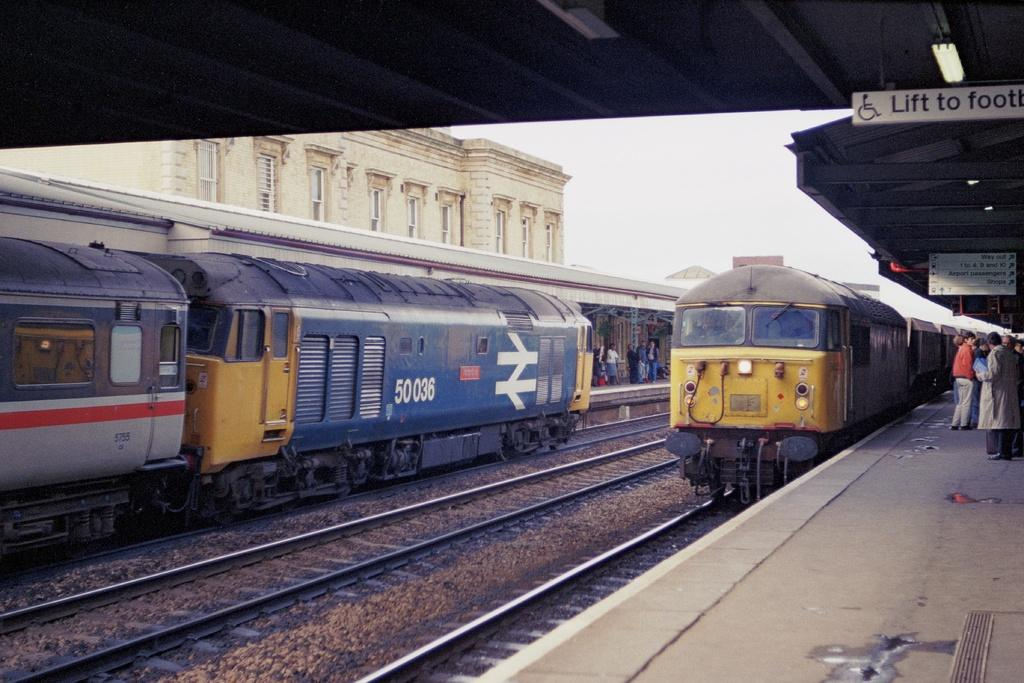<image>
Share a concise interpretation of the image provided. a blue train on the second track has the umber 50036. 